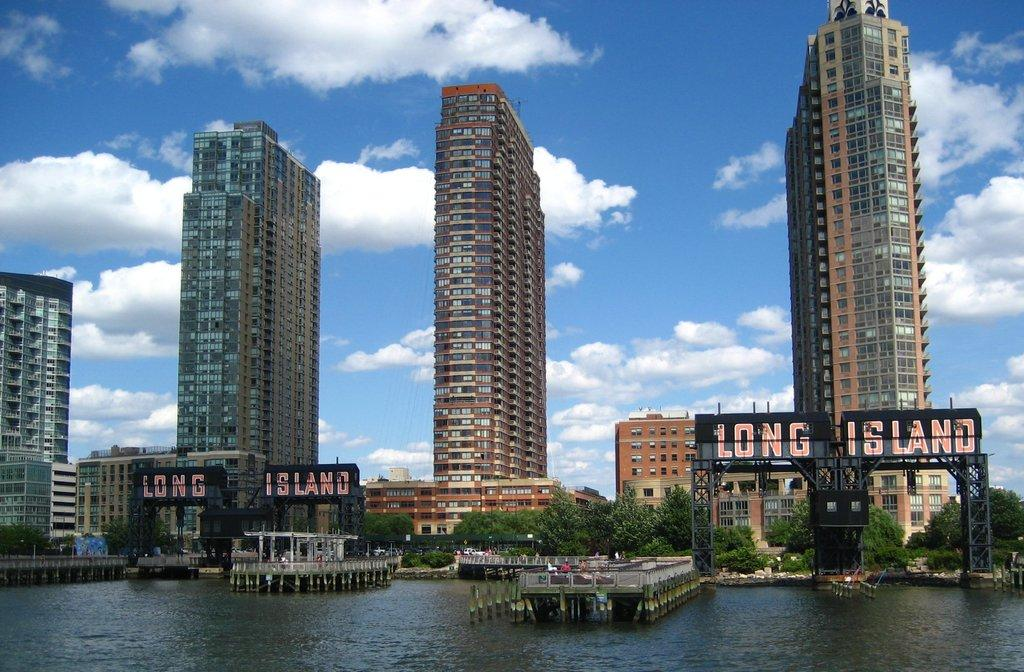Who or what can be seen in the image? There are people in the image. What type of structures are visible in the image? There are buildings in the image. What natural elements can be seen in the image? There are trees in the image. What type of advertisements are present in the image? There are hoardings in the image. What is happening in the water in the image? There are constructions in the water. What materials can be seen in the background of the image? Metal rods are visible in the background. What is visible in the sky in the image? Clouds are present in the background. What type of vase is being used to hold knowledge in the image? There is no vase or knowledge present in the image. What type of pest can be seen crawling on the people in the image? There are no pests visible on the people in the image. 